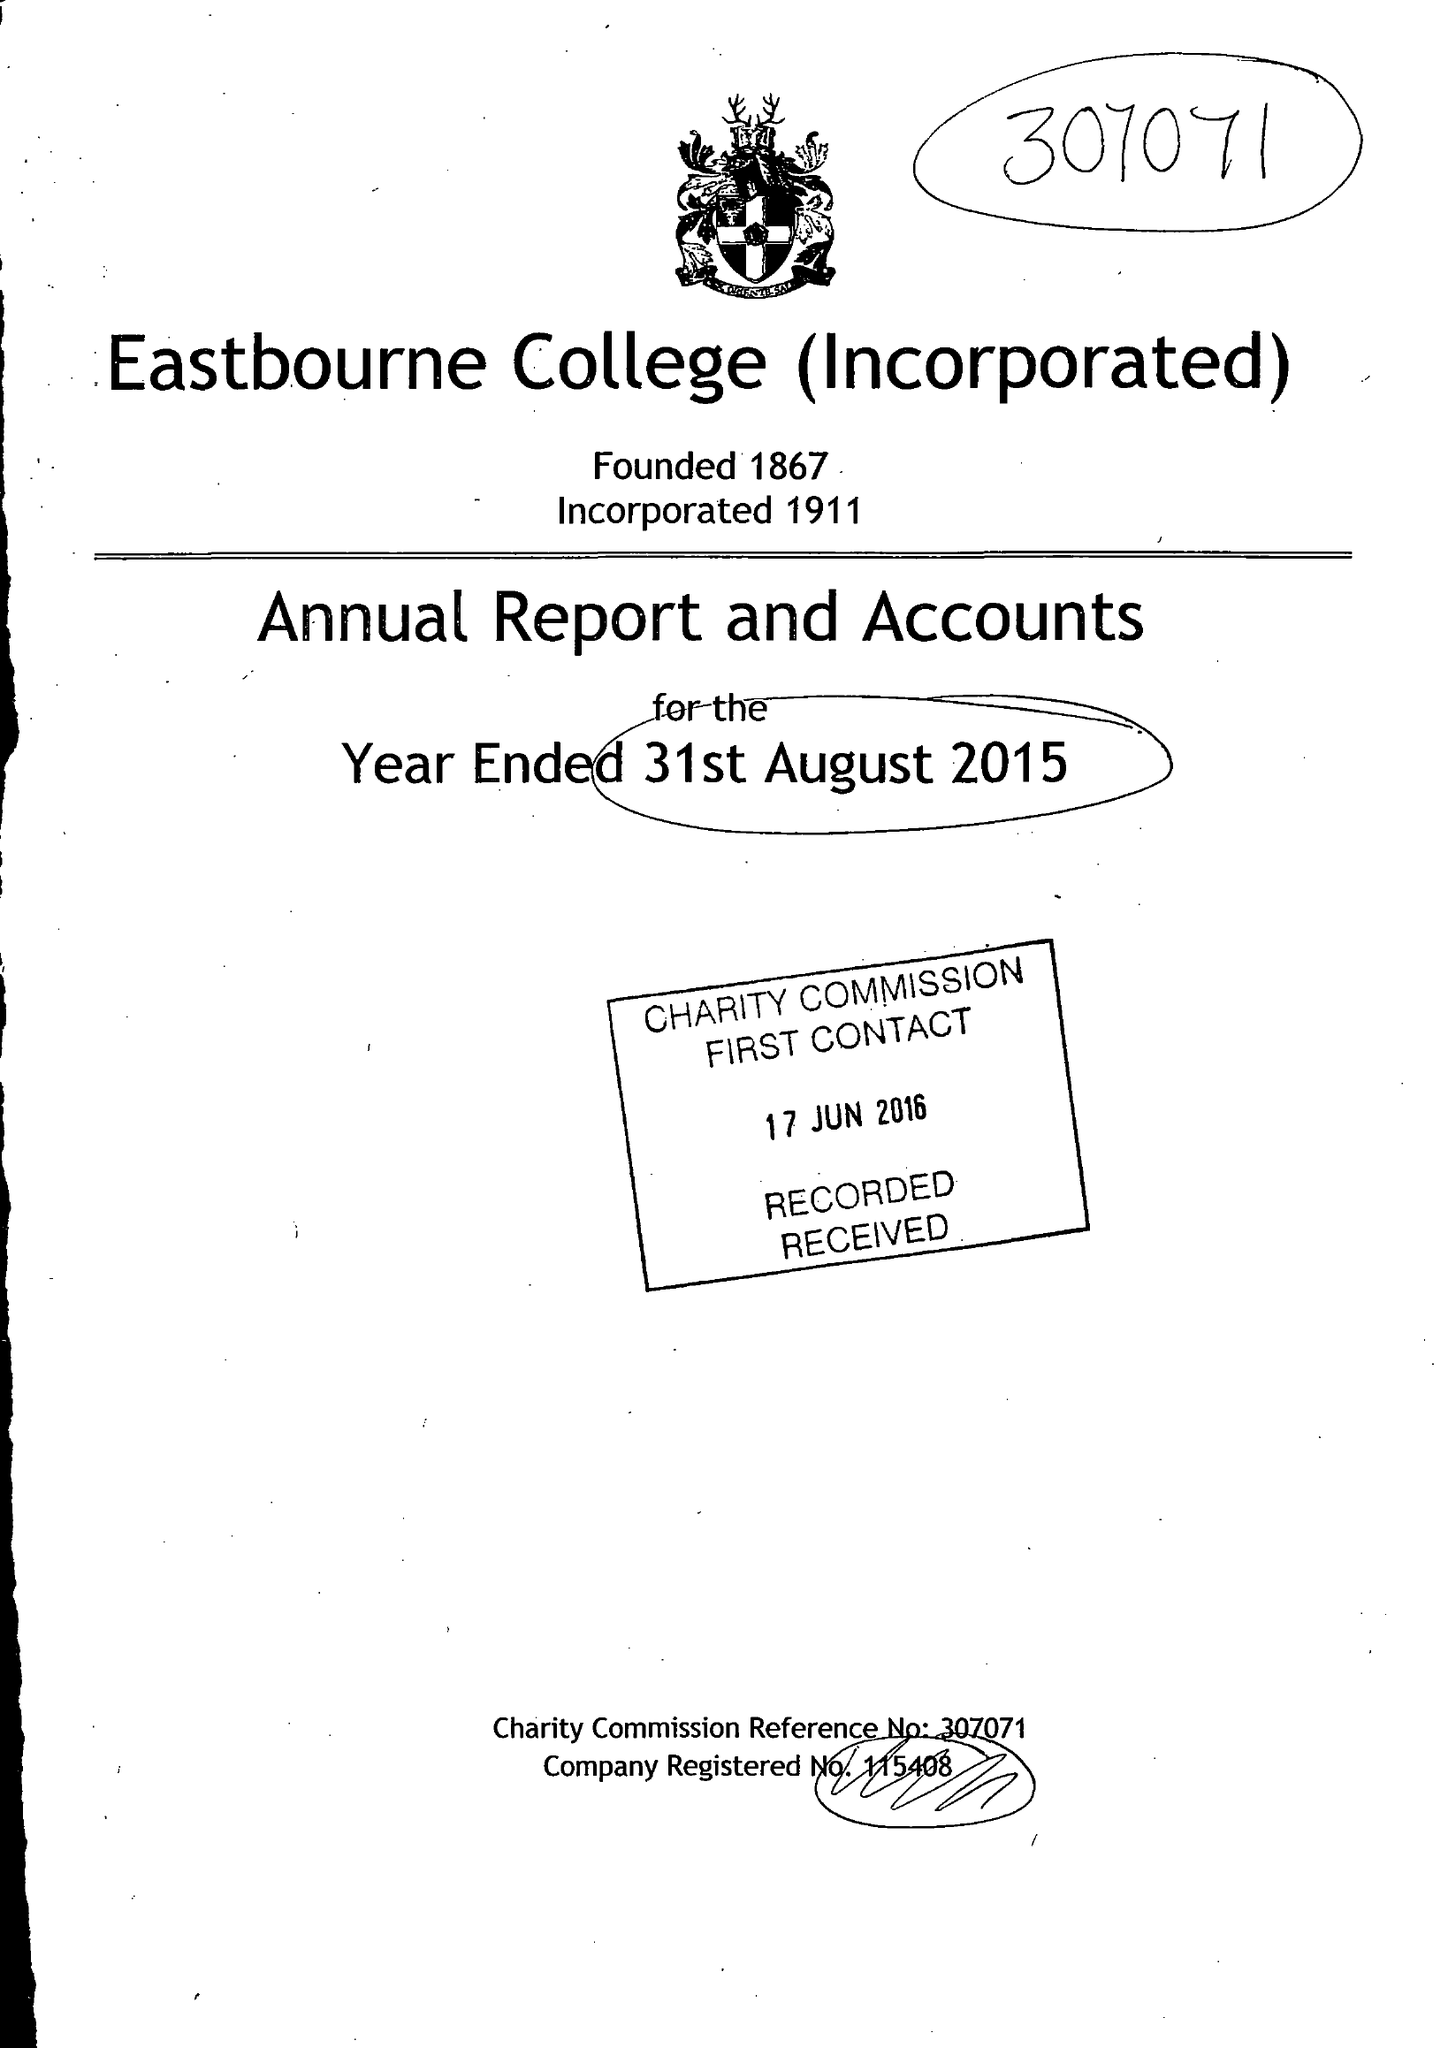What is the value for the charity_number?
Answer the question using a single word or phrase. 307071 